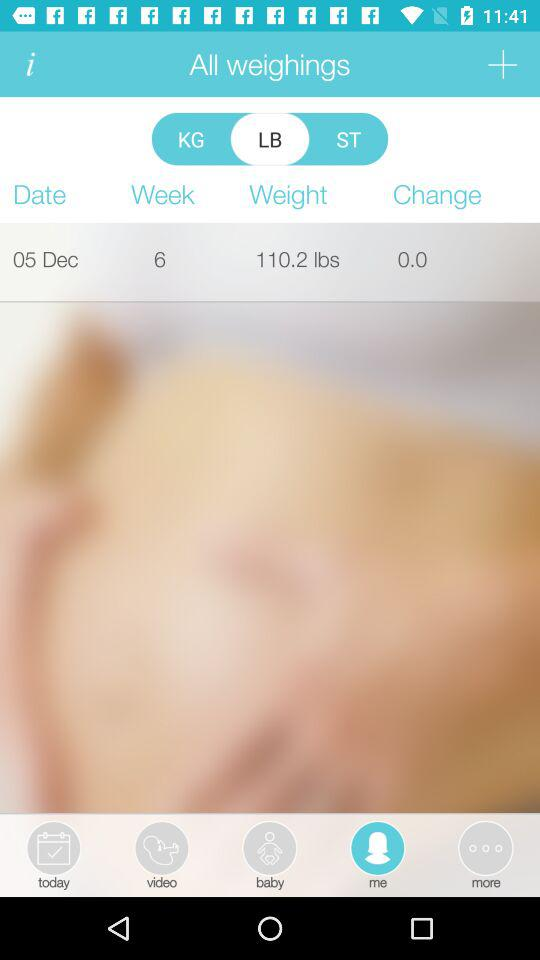What is the displayed date? The displayed date is December 5. 